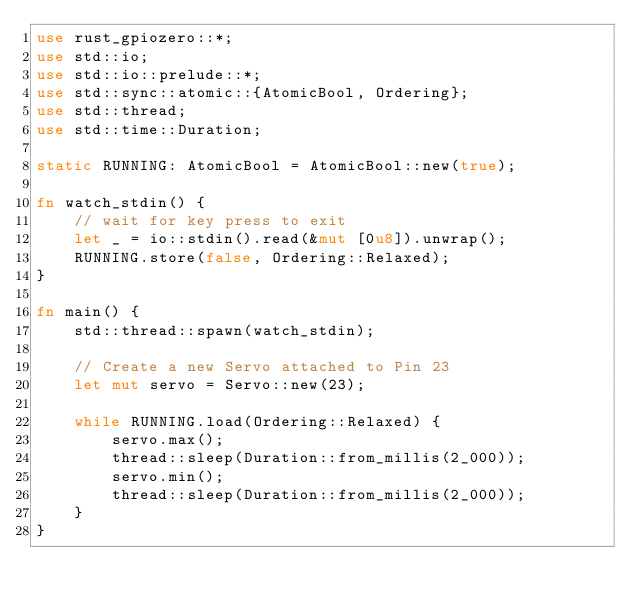<code> <loc_0><loc_0><loc_500><loc_500><_Rust_>use rust_gpiozero::*;
use std::io;
use std::io::prelude::*;
use std::sync::atomic::{AtomicBool, Ordering};
use std::thread;
use std::time::Duration;

static RUNNING: AtomicBool = AtomicBool::new(true);

fn watch_stdin() {
    // wait for key press to exit
    let _ = io::stdin().read(&mut [0u8]).unwrap();
    RUNNING.store(false, Ordering::Relaxed);
}

fn main() {
    std::thread::spawn(watch_stdin);

    // Create a new Servo attached to Pin 23
    let mut servo = Servo::new(23);

    while RUNNING.load(Ordering::Relaxed) {
        servo.max();
        thread::sleep(Duration::from_millis(2_000));
        servo.min();
        thread::sleep(Duration::from_millis(2_000));
    }
}
</code> 